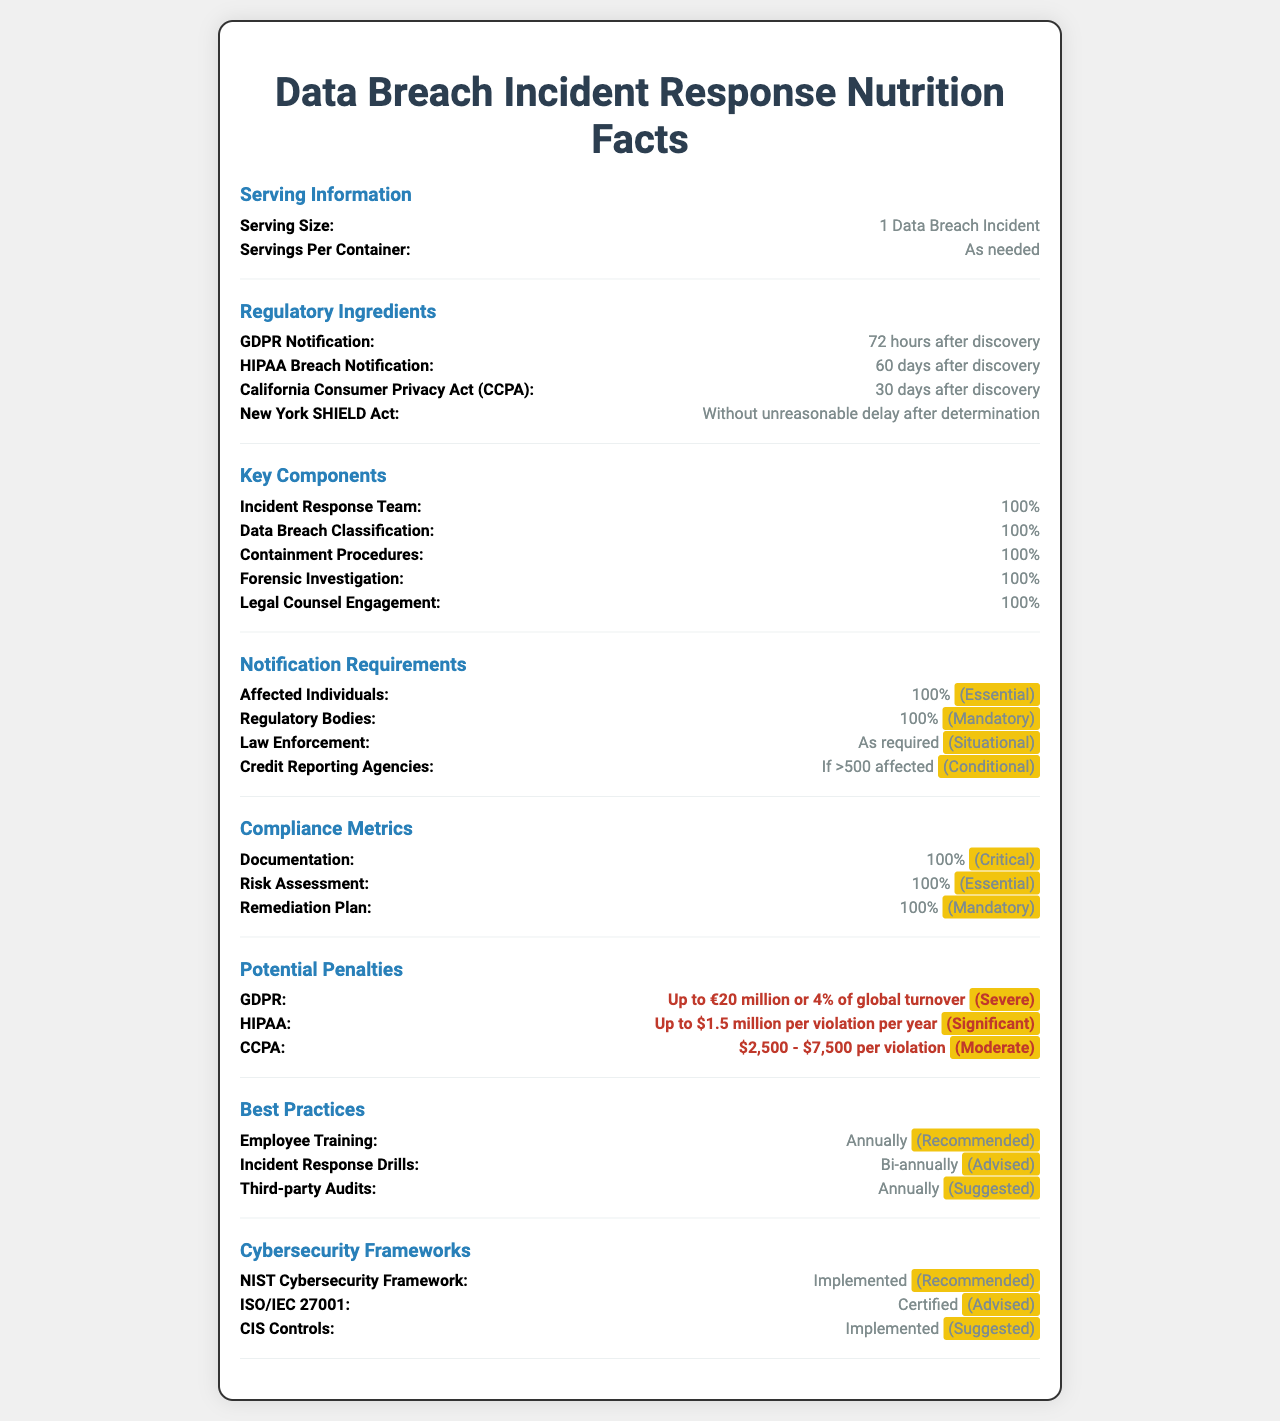what is the serving size of the data breach incident response plan? The serving size is clearly mentioned as "1 Data Breach Incident" in the Serving Information section.
Answer: 1 Data Breach Incident how many days do you have to notify regulatory bodies under HIPAA after discovering a breach? The Regulatory Ingredients section lists HIPAA Breach Notification as 60 days after discovery.
Answer: 60 days list two key components that are essential for an incident response plan. The Key Components section indicates that several items are critical components, including Incident Response Team and Forensic Investigation, both listed as 100%.
Answer: Incident Response Team, Forensic Investigation which regulatory framework is advised for implementation according to the document? A. NIST Cybersecurity Framework B. ISO/IEC 27001 C. CIS Controls The Cybersecurity Frameworks section highlights that ISO/IEC 27001 is listed as "Certified" with a daily value of "Advised".
Answer: B to whom should notification be sent if more than 500 individuals are affected in a data breach? According to the Notification Requirements section, "Credit Reporting Agencies" should be notified if more than 500 individuals are affected.
Answer: Credit Reporting Agencies are there any regulatory bodies that do not have specific penalties detailed in this document? The Potential Penalties section lists penalties for GDPR, HIPAA, and CCPA, covering the mentioned regulatory bodies in the document.
Answer: No summarize the main purpose of this document. This summary captures the purpose laid out in the main sections of the document, each detailing specific requirements and guidelines for incident response.
Answer: The document serves as a comprehensive guide detailing regulatory notification requirements, key components, compliance metrics, potential penalties, best practices, and recognized cybersecurity frameworks for responding to data breach incidents. how long do annual incident response drills need to be conducted? The Best Practices section states that Incident Response Drills should occur "Bi-annually".
Answer: Bi-annually how severe are GDPR potential penalties as indicated in the document? A. Minor B. Moderate C. Severe D. Significant The Potential Penalties section lists GDPR penalties as "Up to €20 million or 4% of global turnover" with a daily value of "Severe".
Answer: C who needs to be notified 100% of the time when a data breach occurs? The Notification Requirements section specifies that both Affected Individuals and Regulatory Bodies with "100%" amount and "Essential" and "Mandatory" daily values respectively.
Answer: Affected Individuals, Regulatory Bodies what is the meaning of "unreasonable delay" in the context of the New York SHIELD Act notification requirement timeframe? The document mentions "Without unreasonable delay" but does not define what timeframe constitutes an unreasonable delay.
Answer: Not enough information 